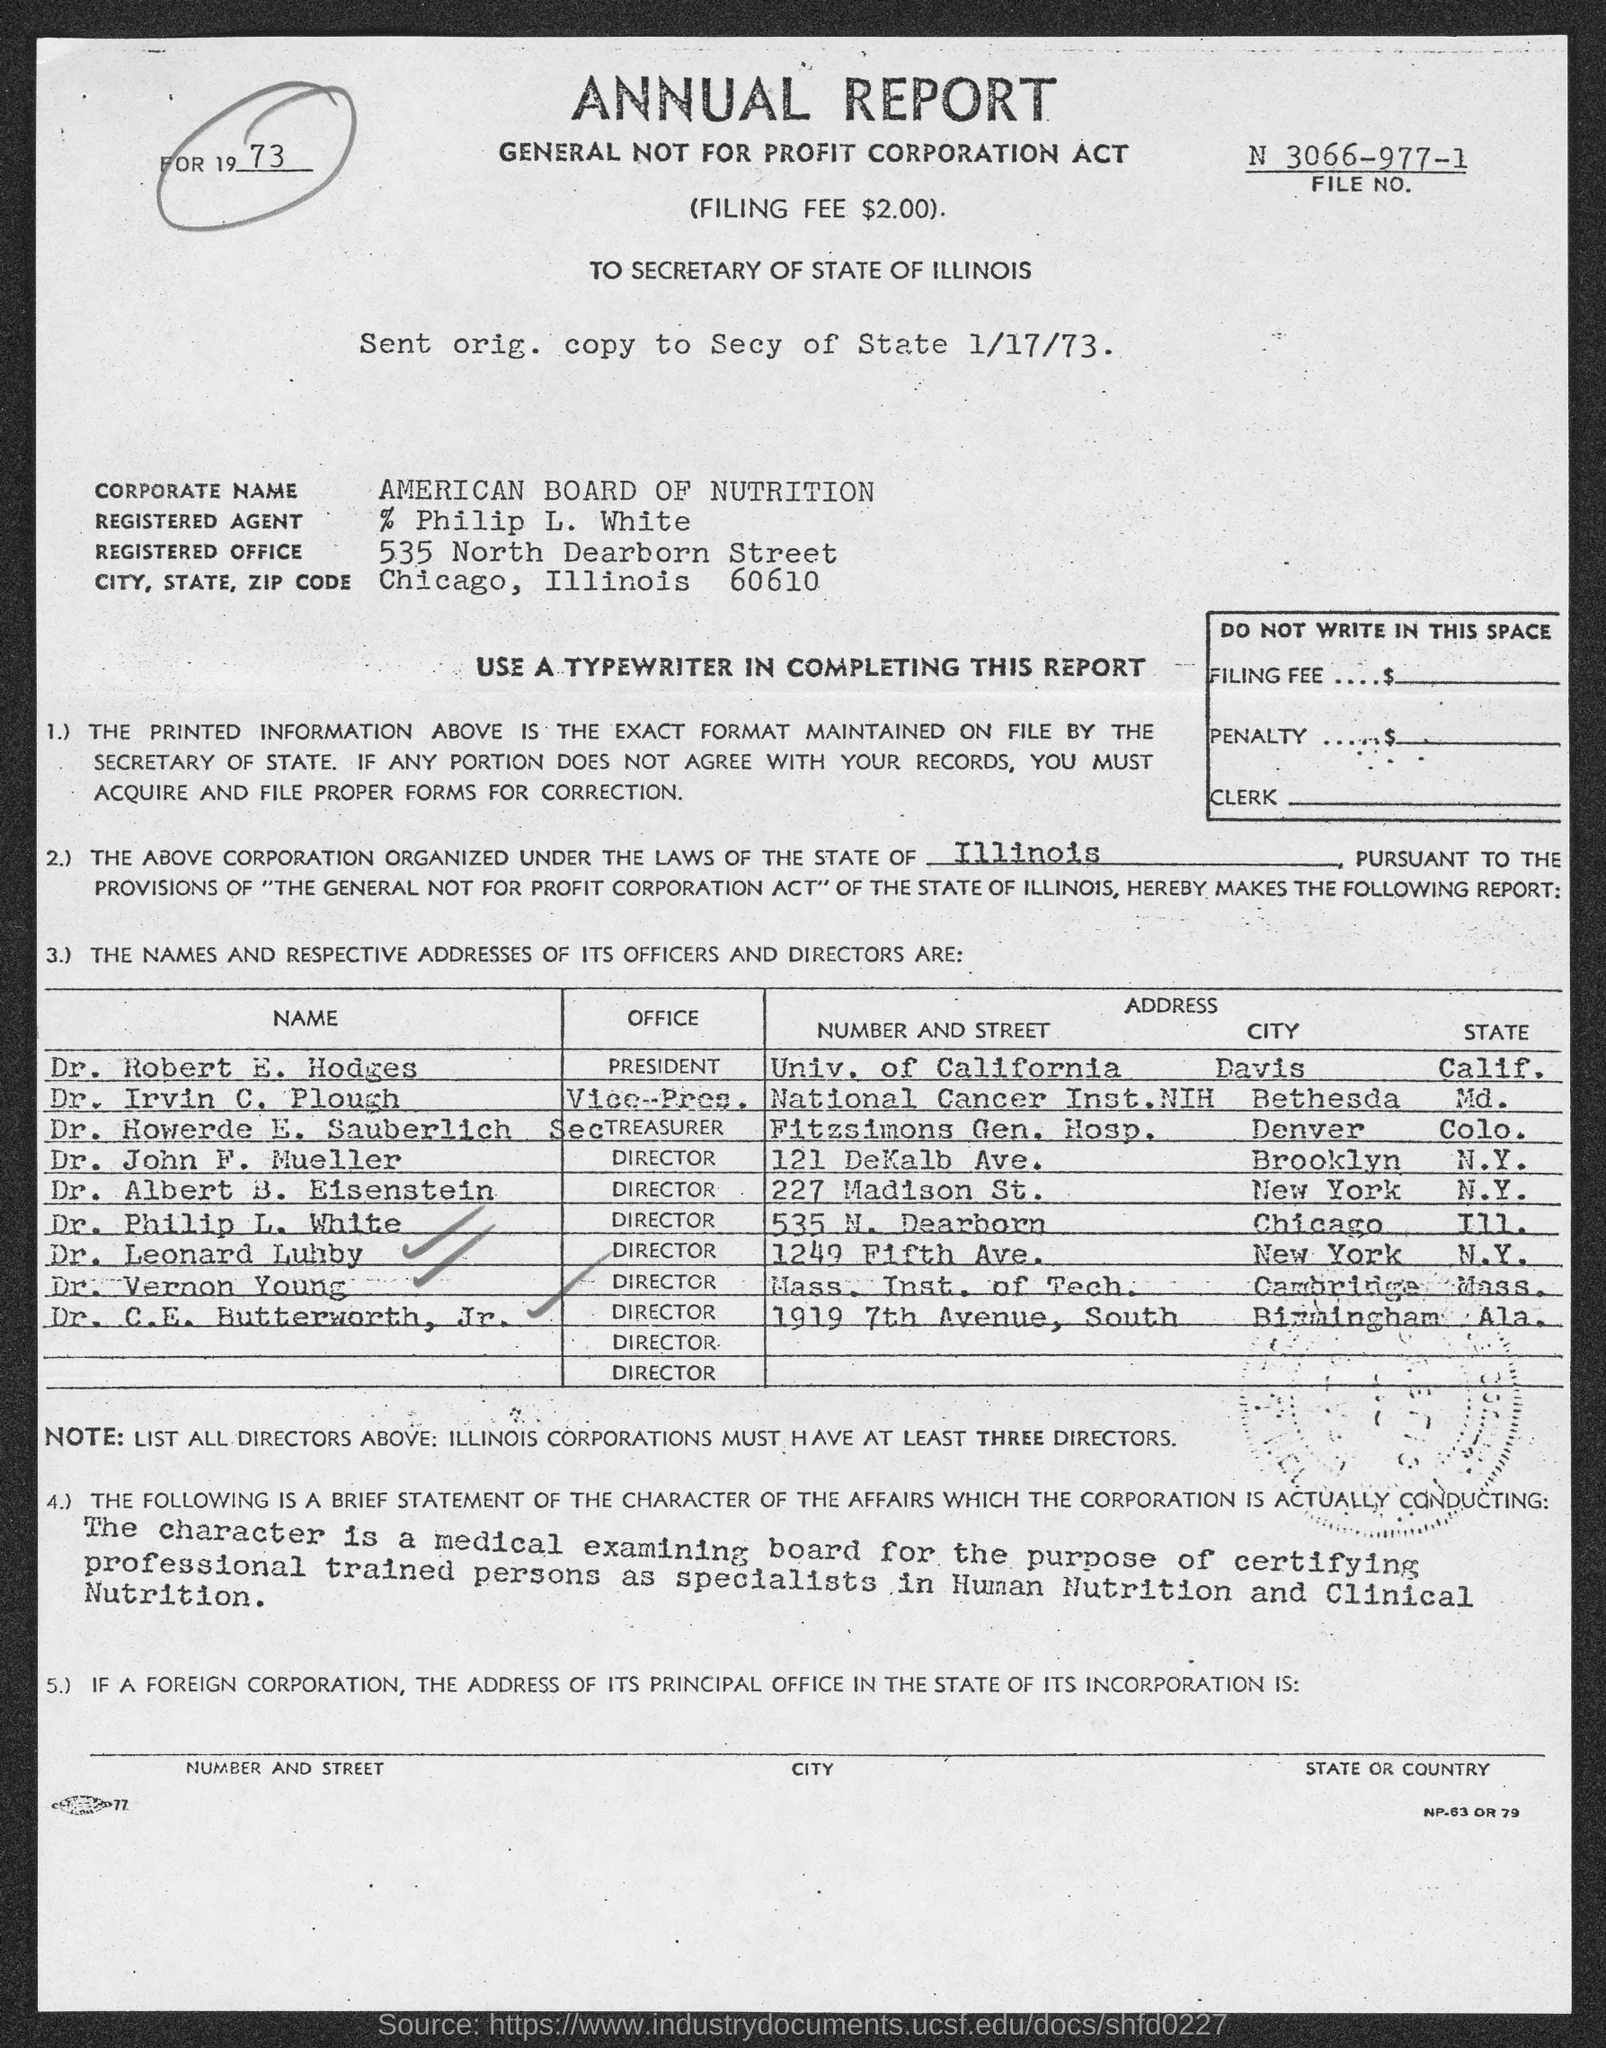What is the filing fee ?
Your response must be concise. $2.00. What is the corporate name ?
Your answer should be very brief. American board of nutrition. What is the registered office address ?
Ensure brevity in your answer.  535 north dearborn street. What is the office of dr. robert e. hodges ?
Provide a short and direct response. President. What is the office of dr. john f. mueller ?
Your response must be concise. Director. What is the office of dr. albert b. eisenstein ?
Keep it short and to the point. Director. What is the office of dr. vernon young?
Give a very brief answer. Director. 